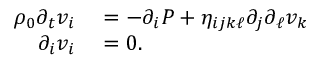<formula> <loc_0><loc_0><loc_500><loc_500>\begin{array} { r l } { \rho _ { 0 } \partial _ { t } v _ { i } } & = - \partial _ { i } P + \eta _ { i j k \ell } \partial _ { j } \partial _ { \ell } v _ { k } } \\ { \partial _ { i } v _ { i } } & = 0 . } \end{array}</formula> 